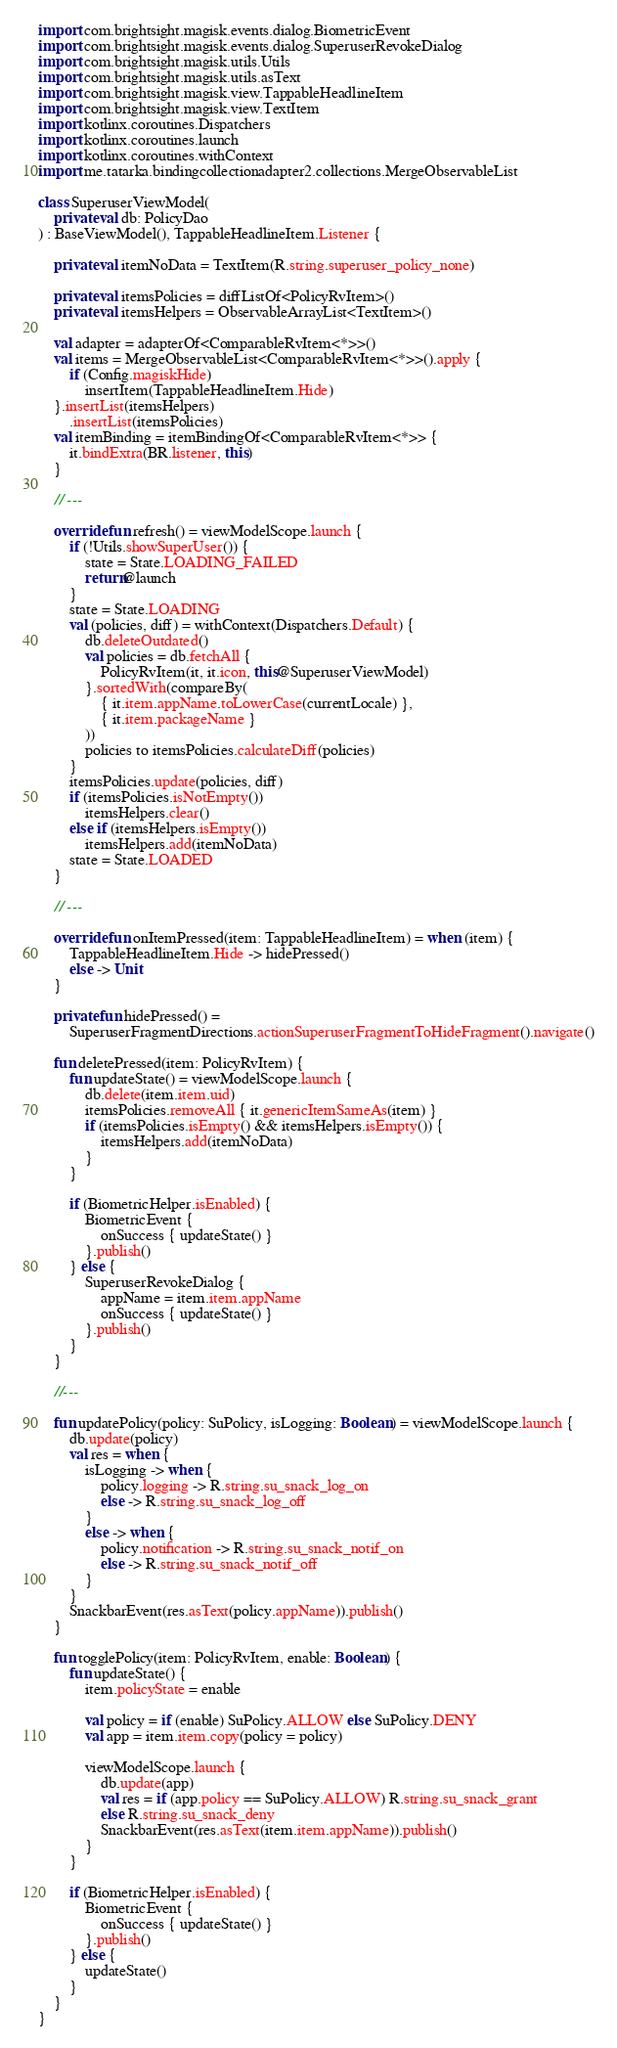<code> <loc_0><loc_0><loc_500><loc_500><_Kotlin_>import com.brightsight.magisk.events.dialog.BiometricEvent
import com.brightsight.magisk.events.dialog.SuperuserRevokeDialog
import com.brightsight.magisk.utils.Utils
import com.brightsight.magisk.utils.asText
import com.brightsight.magisk.view.TappableHeadlineItem
import com.brightsight.magisk.view.TextItem
import kotlinx.coroutines.Dispatchers
import kotlinx.coroutines.launch
import kotlinx.coroutines.withContext
import me.tatarka.bindingcollectionadapter2.collections.MergeObservableList

class SuperuserViewModel(
    private val db: PolicyDao
) : BaseViewModel(), TappableHeadlineItem.Listener {

    private val itemNoData = TextItem(R.string.superuser_policy_none)

    private val itemsPolicies = diffListOf<PolicyRvItem>()
    private val itemsHelpers = ObservableArrayList<TextItem>()

    val adapter = adapterOf<ComparableRvItem<*>>()
    val items = MergeObservableList<ComparableRvItem<*>>().apply {
        if (Config.magiskHide)
            insertItem(TappableHeadlineItem.Hide)
    }.insertList(itemsHelpers)
        .insertList(itemsPolicies)
    val itemBinding = itemBindingOf<ComparableRvItem<*>> {
        it.bindExtra(BR.listener, this)
    }

    // ---

    override fun refresh() = viewModelScope.launch {
        if (!Utils.showSuperUser()) {
            state = State.LOADING_FAILED
            return@launch
        }
        state = State.LOADING
        val (policies, diff) = withContext(Dispatchers.Default) {
            db.deleteOutdated()
            val policies = db.fetchAll {
                PolicyRvItem(it, it.icon, this@SuperuserViewModel)
            }.sortedWith(compareBy(
                { it.item.appName.toLowerCase(currentLocale) },
                { it.item.packageName }
            ))
            policies to itemsPolicies.calculateDiff(policies)
        }
        itemsPolicies.update(policies, diff)
        if (itemsPolicies.isNotEmpty())
            itemsHelpers.clear()
        else if (itemsHelpers.isEmpty())
            itemsHelpers.add(itemNoData)
        state = State.LOADED
    }

    // ---

    override fun onItemPressed(item: TappableHeadlineItem) = when (item) {
        TappableHeadlineItem.Hide -> hidePressed()
        else -> Unit
    }

    private fun hidePressed() =
        SuperuserFragmentDirections.actionSuperuserFragmentToHideFragment().navigate()

    fun deletePressed(item: PolicyRvItem) {
        fun updateState() = viewModelScope.launch {
            db.delete(item.item.uid)
            itemsPolicies.removeAll { it.genericItemSameAs(item) }
            if (itemsPolicies.isEmpty() && itemsHelpers.isEmpty()) {
                itemsHelpers.add(itemNoData)
            }
        }

        if (BiometricHelper.isEnabled) {
            BiometricEvent {
                onSuccess { updateState() }
            }.publish()
        } else {
            SuperuserRevokeDialog {
                appName = item.item.appName
                onSuccess { updateState() }
            }.publish()
        }
    }

    //---

    fun updatePolicy(policy: SuPolicy, isLogging: Boolean) = viewModelScope.launch {
        db.update(policy)
        val res = when {
            isLogging -> when {
                policy.logging -> R.string.su_snack_log_on
                else -> R.string.su_snack_log_off
            }
            else -> when {
                policy.notification -> R.string.su_snack_notif_on
                else -> R.string.su_snack_notif_off
            }
        }
        SnackbarEvent(res.asText(policy.appName)).publish()
    }

    fun togglePolicy(item: PolicyRvItem, enable: Boolean) {
        fun updateState() {
            item.policyState = enable

            val policy = if (enable) SuPolicy.ALLOW else SuPolicy.DENY
            val app = item.item.copy(policy = policy)

            viewModelScope.launch {
                db.update(app)
                val res = if (app.policy == SuPolicy.ALLOW) R.string.su_snack_grant
                else R.string.su_snack_deny
                SnackbarEvent(res.asText(item.item.appName)).publish()
            }
        }

        if (BiometricHelper.isEnabled) {
            BiometricEvent {
                onSuccess { updateState() }
            }.publish()
        } else {
            updateState()
        }
    }
}
</code> 